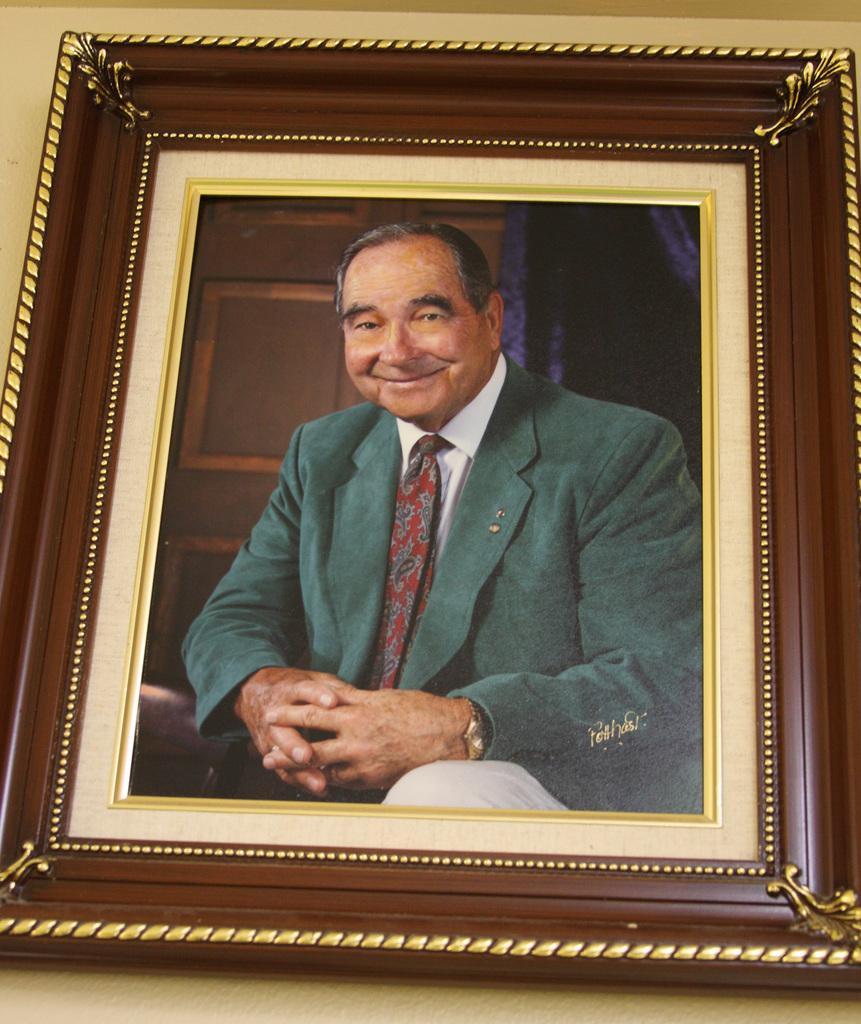In one or two sentences, can you explain what this image depicts? In this picture, we can see the wall with a photo frame of a person. 